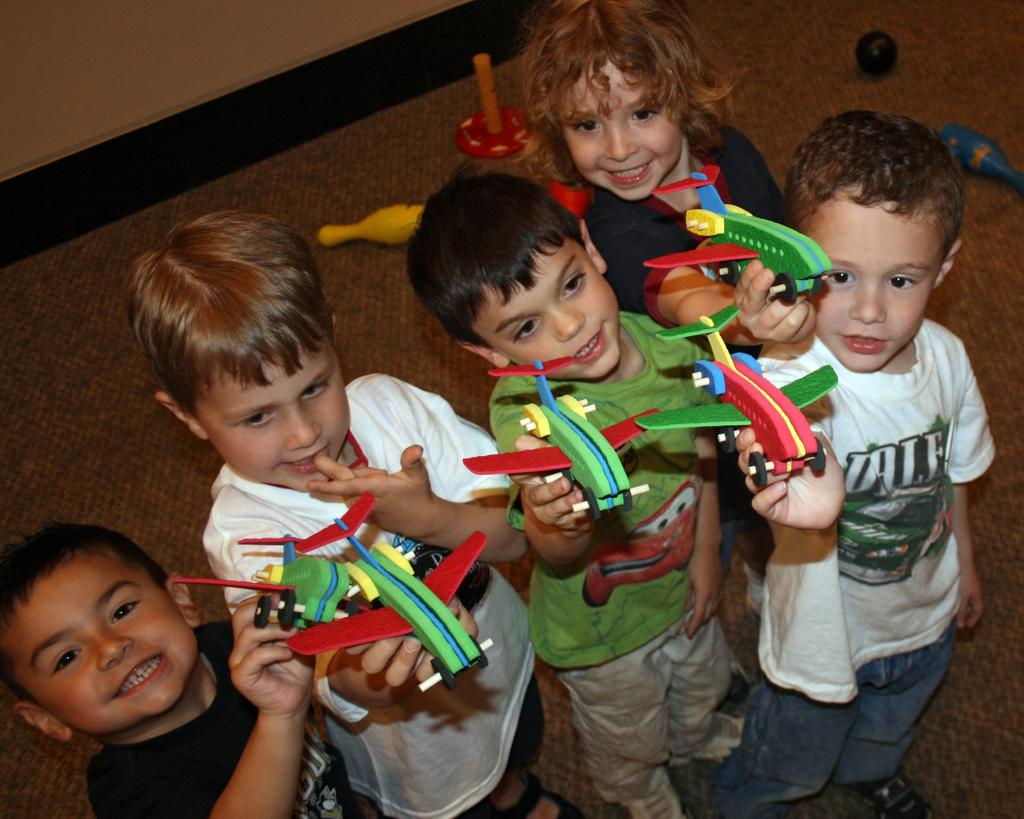How many kids are present in the image? There are five kids in the image. What are the kids holding in their hands? The kids are holding toys in their hands. What can be seen in the background of the image? There is a wall in the background of the image. What else can be seen on the floor in the image? There are toys on the floor in the image. What type of produce can be seen in the image? There is no produce present in the image; it features kids holding toys and toys on the floor. 